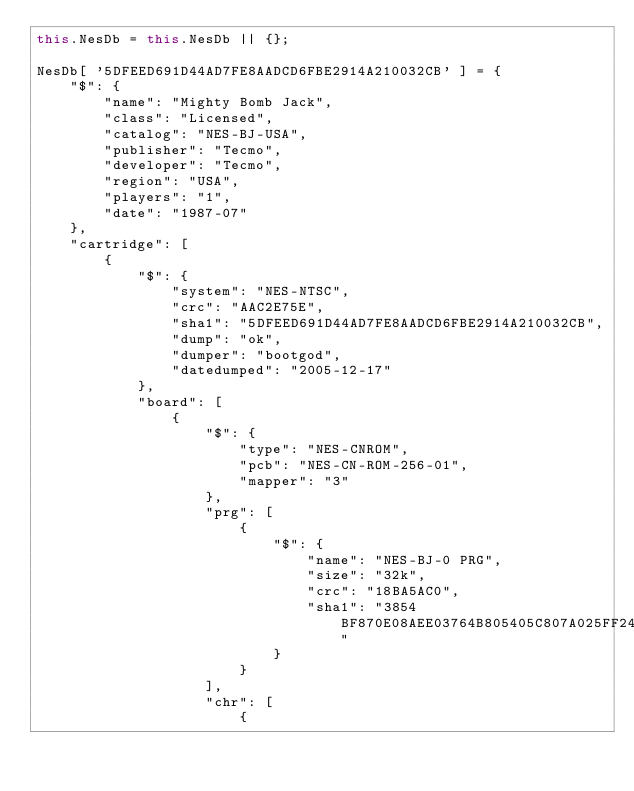Convert code to text. <code><loc_0><loc_0><loc_500><loc_500><_JavaScript_>this.NesDb = this.NesDb || {};

NesDb[ '5DFEED691D44AD7FE8AADCD6FBE2914A210032CB' ] = {
	"$": {
		"name": "Mighty Bomb Jack",
		"class": "Licensed",
		"catalog": "NES-BJ-USA",
		"publisher": "Tecmo",
		"developer": "Tecmo",
		"region": "USA",
		"players": "1",
		"date": "1987-07"
	},
	"cartridge": [
		{
			"$": {
				"system": "NES-NTSC",
				"crc": "AAC2E75E",
				"sha1": "5DFEED691D44AD7FE8AADCD6FBE2914A210032CB",
				"dump": "ok",
				"dumper": "bootgod",
				"datedumped": "2005-12-17"
			},
			"board": [
				{
					"$": {
						"type": "NES-CNROM",
						"pcb": "NES-CN-ROM-256-01",
						"mapper": "3"
					},
					"prg": [
						{
							"$": {
								"name": "NES-BJ-0 PRG",
								"size": "32k",
								"crc": "18BA5AC0",
								"sha1": "3854BF870E08AEE03764B805405C807A025FF24A"
							}
						}
					],
					"chr": [
						{</code> 